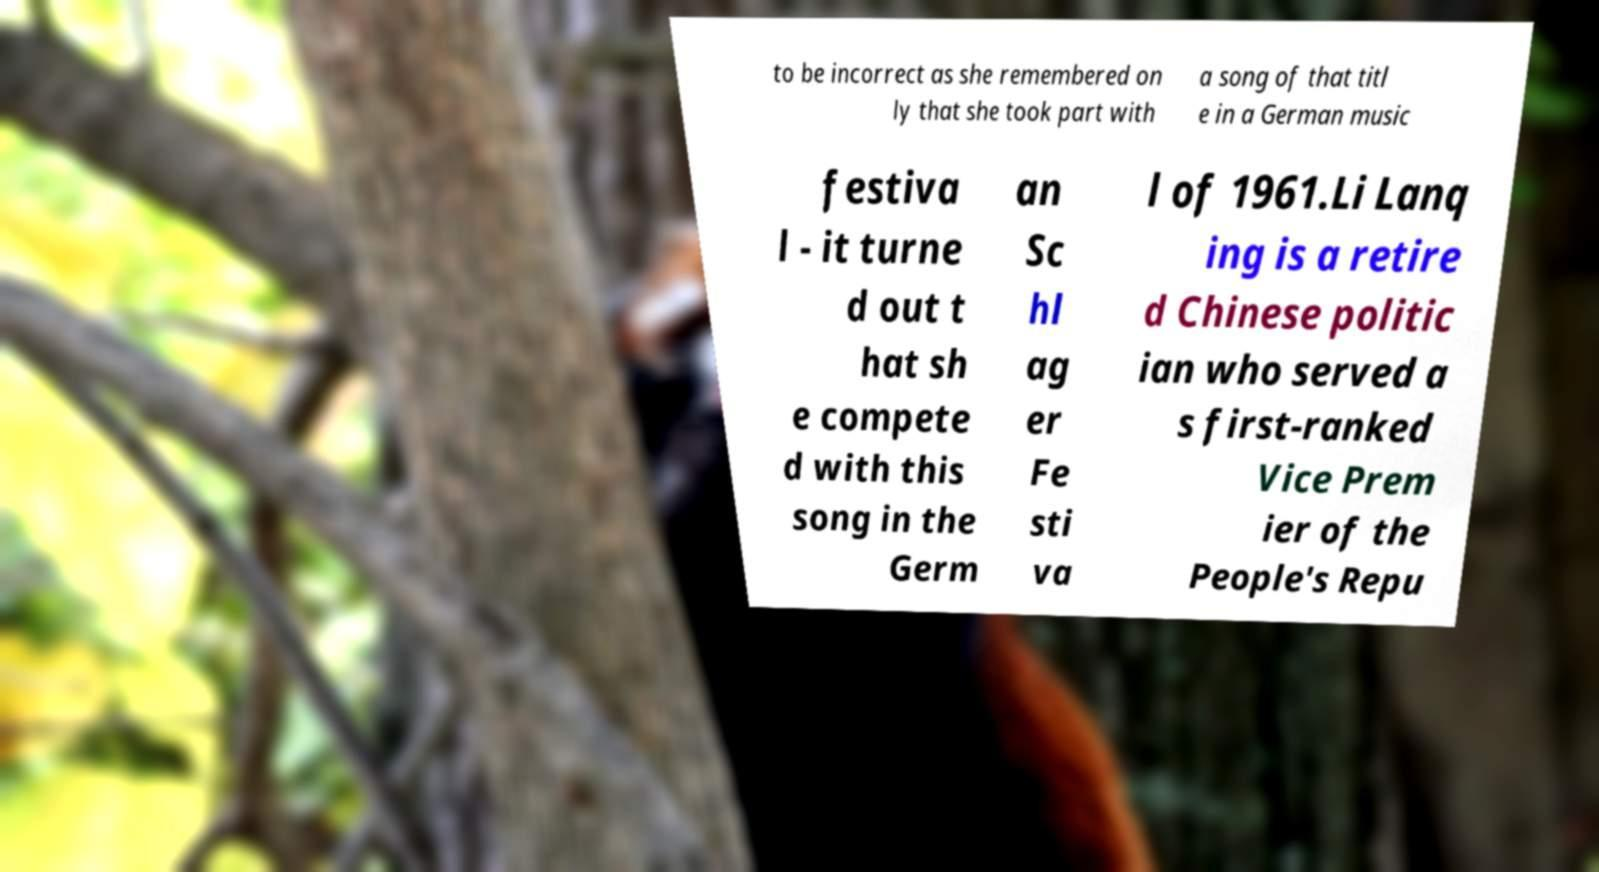Please identify and transcribe the text found in this image. to be incorrect as she remembered on ly that she took part with a song of that titl e in a German music festiva l - it turne d out t hat sh e compete d with this song in the Germ an Sc hl ag er Fe sti va l of 1961.Li Lanq ing is a retire d Chinese politic ian who served a s first-ranked Vice Prem ier of the People's Repu 